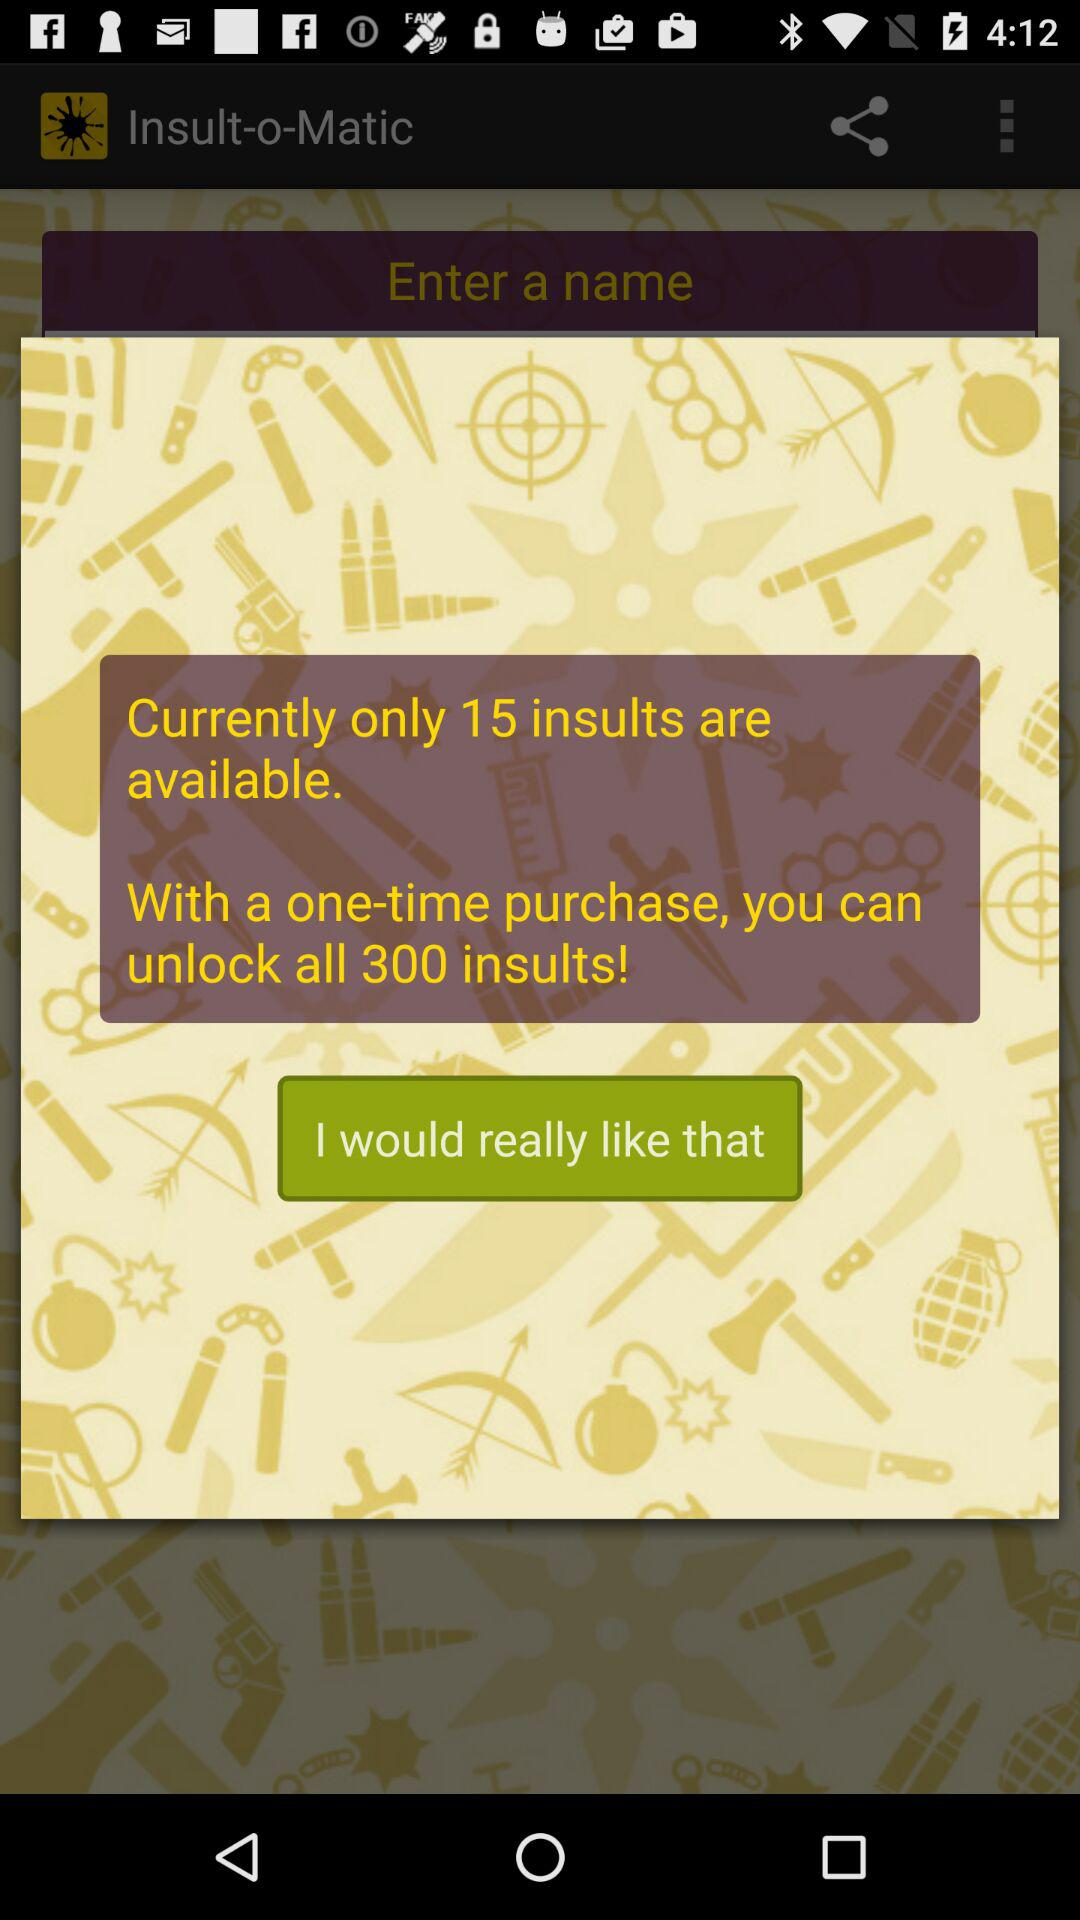How many insults can be unlocked in a one-time purchase? There are 300 insults that can be unlocked. 